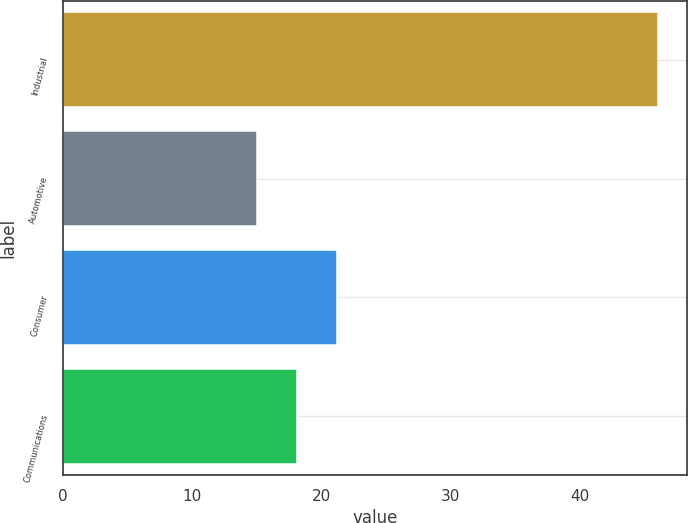<chart> <loc_0><loc_0><loc_500><loc_500><bar_chart><fcel>Industrial<fcel>Automotive<fcel>Consumer<fcel>Communications<nl><fcel>46<fcel>15<fcel>21.2<fcel>18.1<nl></chart> 